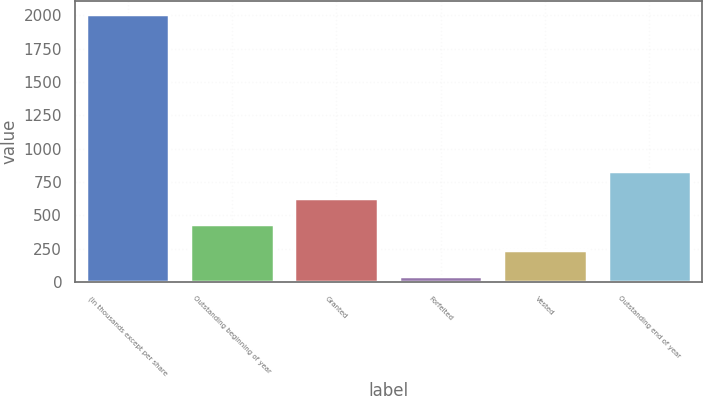Convert chart to OTSL. <chart><loc_0><loc_0><loc_500><loc_500><bar_chart><fcel>(In thousands except per share<fcel>Outstanding beginning of year<fcel>Granted<fcel>Forfeited<fcel>Vested<fcel>Outstanding end of year<nl><fcel>2008<fcel>437.6<fcel>633.9<fcel>45<fcel>241.3<fcel>830.2<nl></chart> 